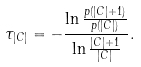<formula> <loc_0><loc_0><loc_500><loc_500>\tau _ { | C | } = - \frac { \ln \frac { p ( | C | + 1 ) } { p ( | C | ) } } { \ln \frac { | C | + 1 } { | C | } } .</formula> 